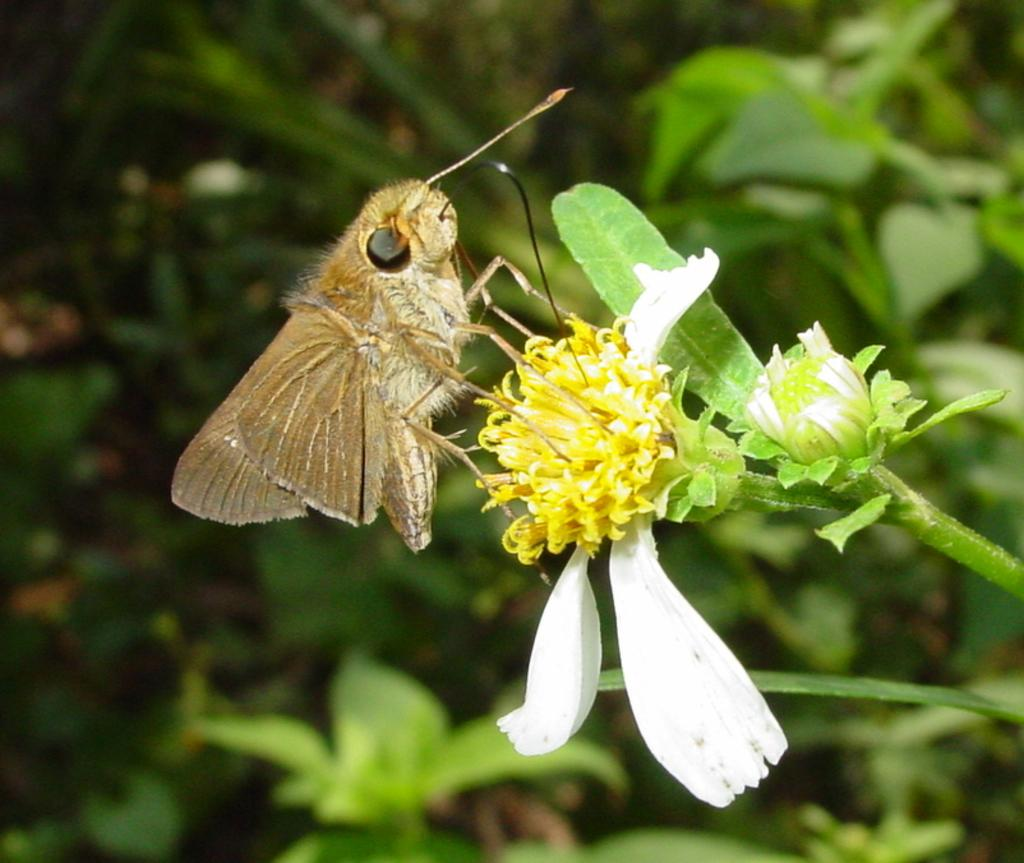What is the main subject of the picture? The main subject of the picture is an insect. What is the insect doing in the picture? The insect is flying on a flower. What else can be seen in the picture besides the insect? There are buds of a plant and more plants visible in the blurred background. What type of dock can be seen in the background of the image? There is no dock present in the image; it features an insect flying on a flower and plants in the background. What flavor of goose is depicted in the image? There is no goose present in the image, and therefore no flavor can be determined. 